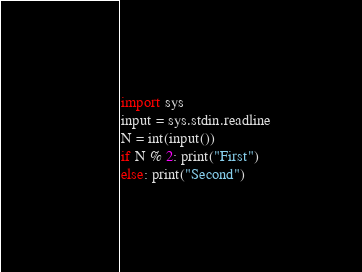<code> <loc_0><loc_0><loc_500><loc_500><_Python_>import sys
input = sys.stdin.readline
N = int(input())
if N % 2: print("First")
else: print("Second")</code> 